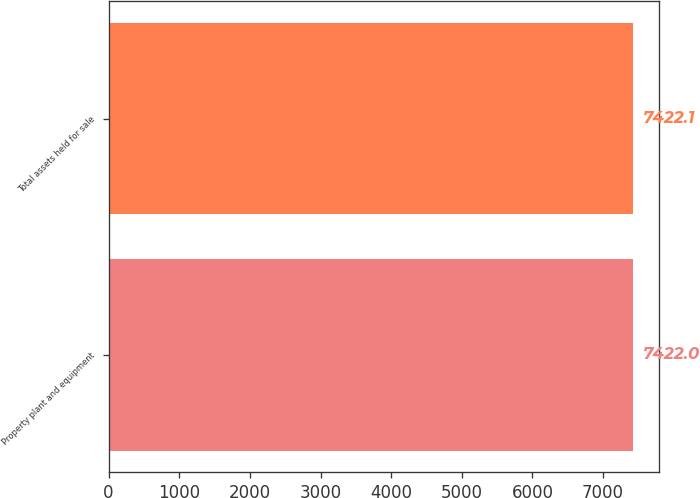Convert chart to OTSL. <chart><loc_0><loc_0><loc_500><loc_500><bar_chart><fcel>Property plant and equipment<fcel>Total assets held for sale<nl><fcel>7422<fcel>7422.1<nl></chart> 